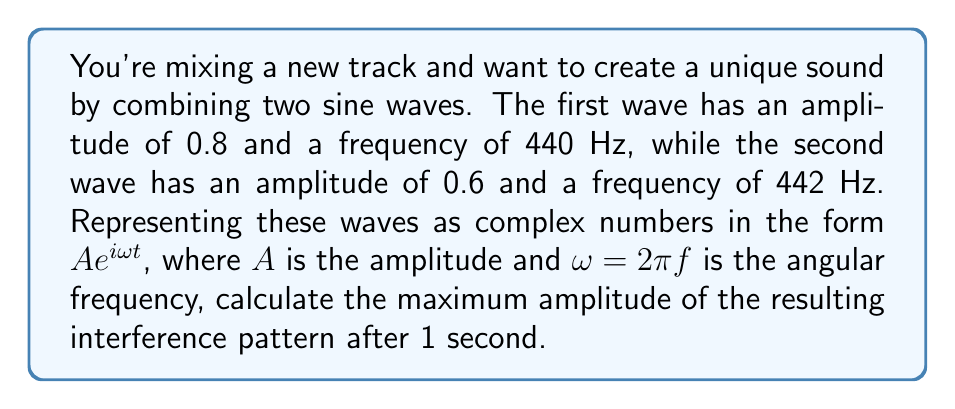Can you solve this math problem? Let's approach this step-by-step:

1) First, we need to represent each wave as a complex number:

   Wave 1: $z_1 = 0.8 e^{i(2\pi \cdot 440)t}$
   Wave 2: $z_2 = 0.6 e^{i(2\pi \cdot 442)t}$

2) The interference pattern is the sum of these waves:

   $z = z_1 + z_2 = 0.8 e^{i(2\pi \cdot 440)t} + 0.6 e^{i(2\pi \cdot 442)t}$

3) At t = 1 second:

   $z = 0.8 e^{i(2\pi \cdot 440)} + 0.6 e^{i(2\pi \cdot 442)}$

4) To find the amplitude, we need to calculate the magnitude of this complex number:

   $|z| = \sqrt{(\text{Re}(z))^2 + (\text{Im}(z))^2}$

5) Real part:
   $\text{Re}(z) = 0.8 \cos(2\pi \cdot 440) + 0.6 \cos(2\pi \cdot 442)$

6) Imaginary part:
   $\text{Im}(z) = 0.8 \sin(2\pi \cdot 440) + 0.6 \sin(2\pi \cdot 442)$

7) Calculating:
   $\text{Re}(z) \approx 0.8 + 0.6 = 1.4$
   $\text{Im}(z) \approx 0$

8) Therefore:
   $|z| = \sqrt{1.4^2 + 0^2} = 1.4$

The maximum amplitude occurs when the waves are in phase, which is what we've calculated here.
Answer: 1.4 